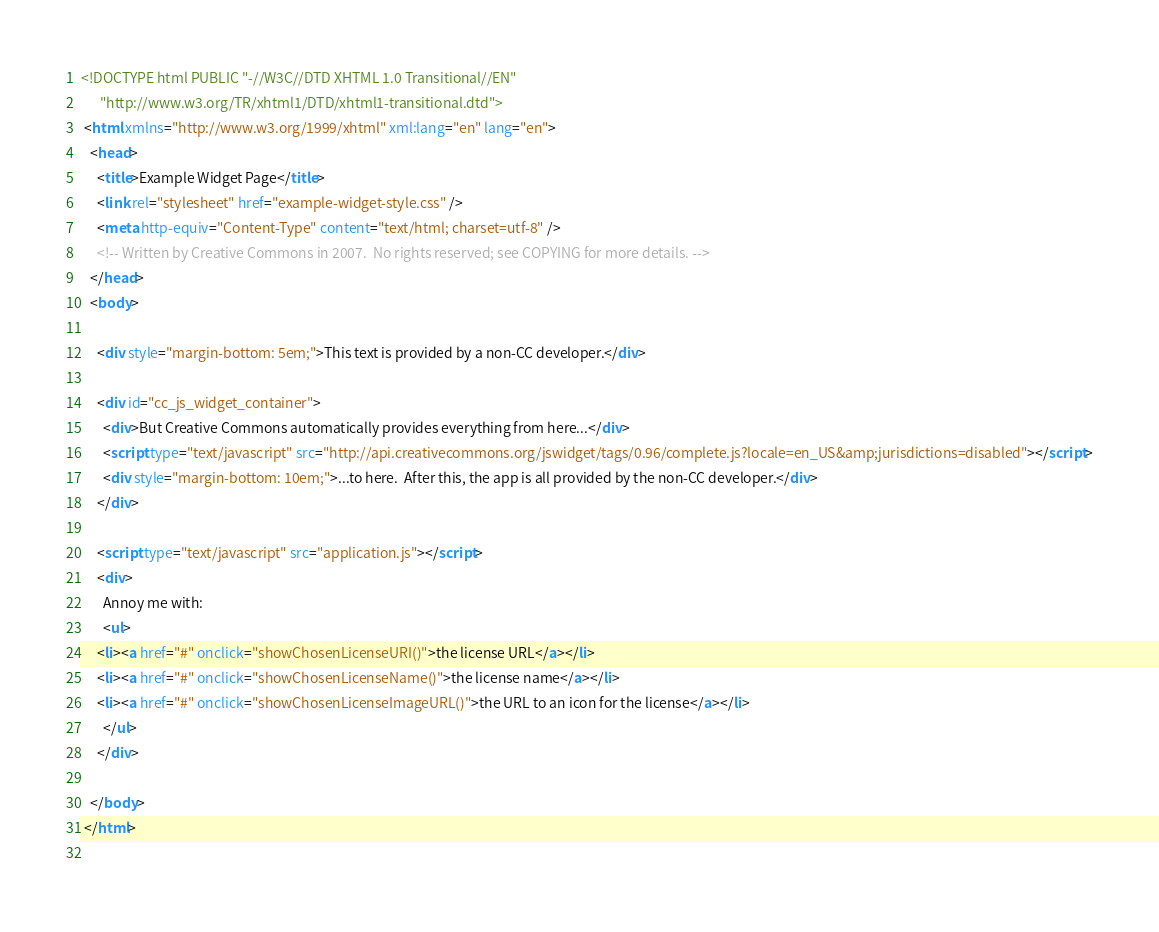<code> <loc_0><loc_0><loc_500><loc_500><_HTML_><!DOCTYPE html PUBLIC "-//W3C//DTD XHTML 1.0 Transitional//EN"
	  "http://www.w3.org/TR/xhtml1/DTD/xhtml1-transitional.dtd">
 <html xmlns="http://www.w3.org/1999/xhtml" xml:lang="en" lang="en">
   <head>
     <title>Example Widget Page</title>
     <link rel="stylesheet" href="example-widget-style.css" />
     <meta http-equiv="Content-Type" content="text/html; charset=utf-8" />
     <!-- Written by Creative Commons in 2007.  No rights reserved; see COPYING for more details. -->
   </head>
   <body>
     
     <div style="margin-bottom: 5em;">This text is provided by a non-CC developer.</div>

     <div id="cc_js_widget_container">
       <div>But Creative Commons automatically provides everything from here...</div>
       <script type="text/javascript" src="http://api.creativecommons.org/jswidget/tags/0.96/complete.js?locale=en_US&amp;jurisdictions=disabled"></script>
       <div style="margin-bottom: 10em;">...to here.  After this, the app is all provided by the non-CC developer.</div>
     </div>
     
     <script type="text/javascript" src="application.js"></script>
     <div>
       Annoy me with:
       <ul>
	 <li><a href="#" onclick="showChosenLicenseURI()">the license URL</a></li>
	 <li><a href="#" onclick="showChosenLicenseName()">the license name</a></li>
	 <li><a href="#" onclick="showChosenLicenseImageURL()">the URL to an icon for the license</a></li>
       </ul>
     </div>

   </body>
 </html>
 
</code> 